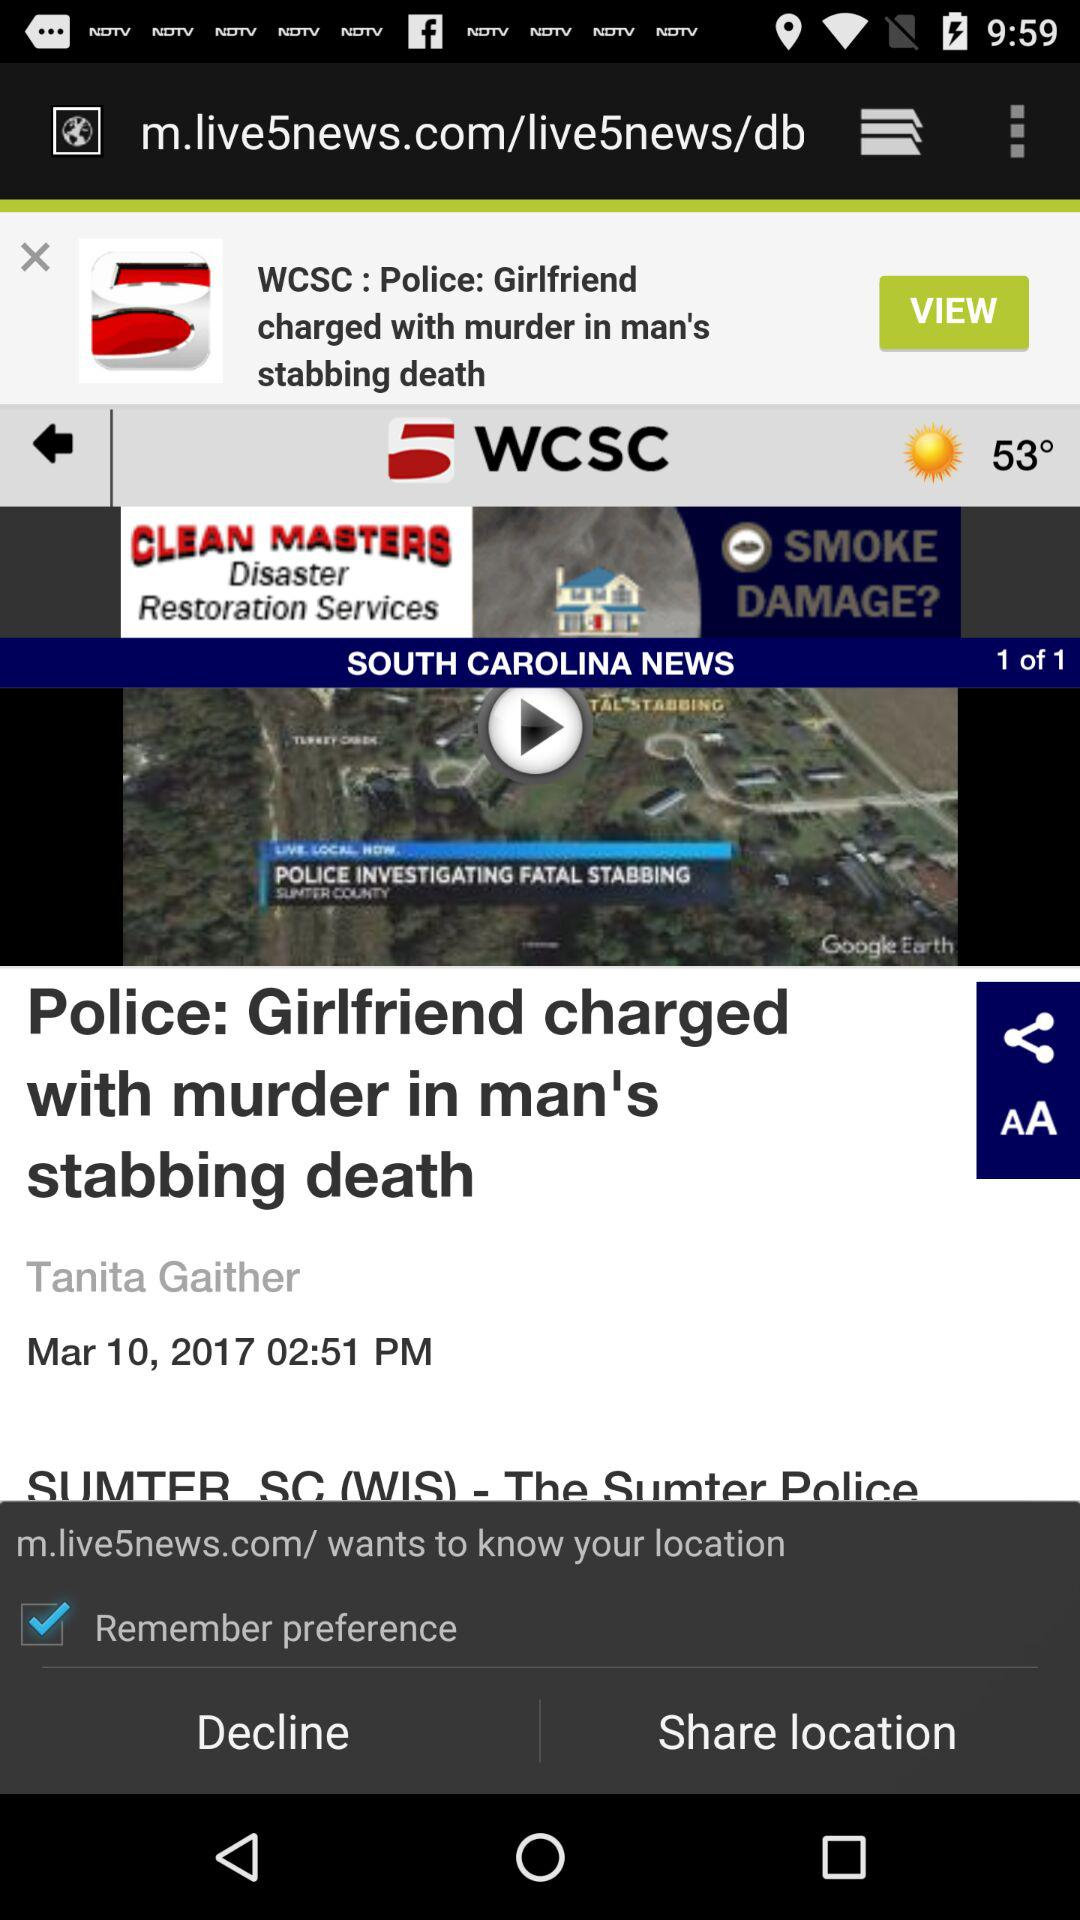What is the status of "Remember preference"? The status is "on". 